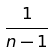<formula> <loc_0><loc_0><loc_500><loc_500>\frac { 1 } { n - 1 }</formula> 